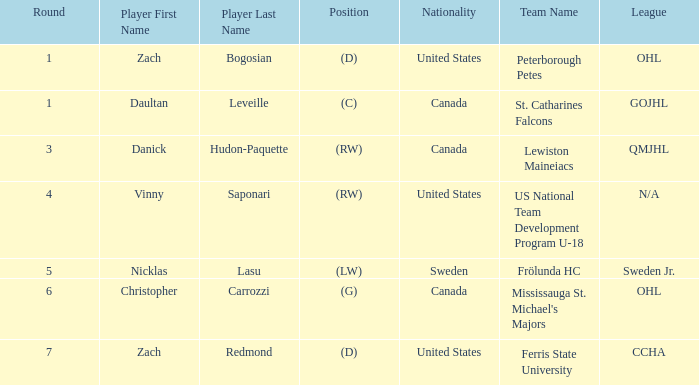What is Daultan Leveille's Position? (C). 